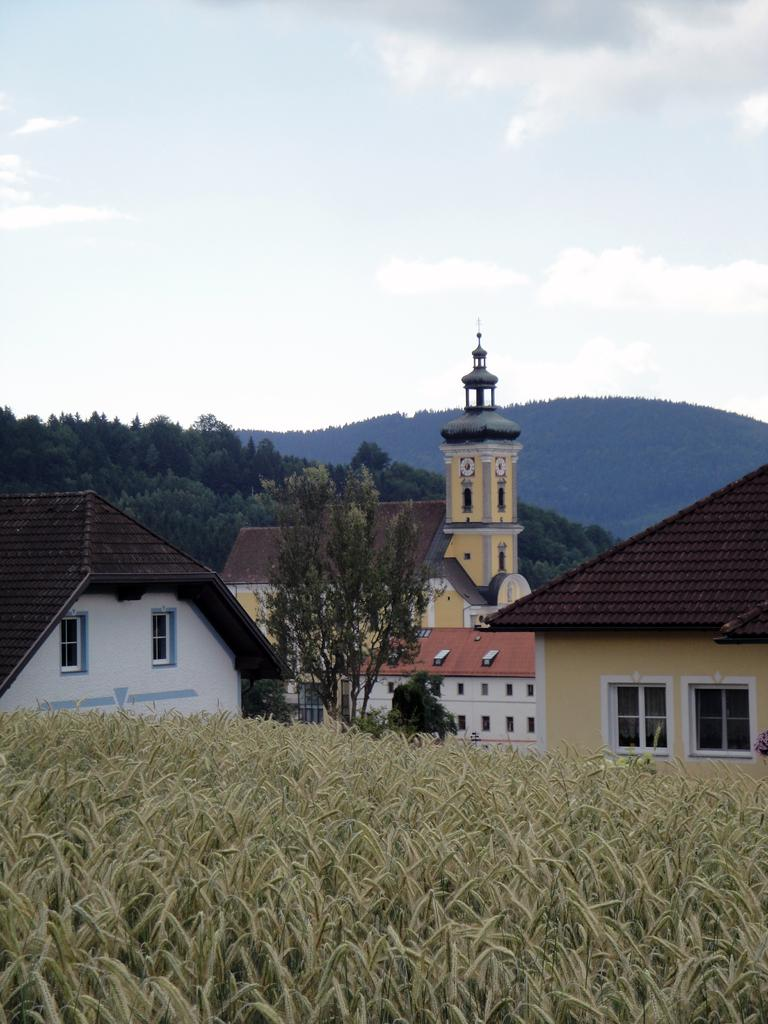What is located in the foreground of the image? There are plants in the foreground of the image. What can be seen in the background of the image? There are houses, trees, and mountains in the background of the image. What is visible at the top of the image? The sky is visible at the top of the image. How many times does the roll of paper appear in the image? There is no roll of paper present in the image. What type of screwdriver is being used to crack open the nut in the image? There is no screwdriver or nut present in the image. 